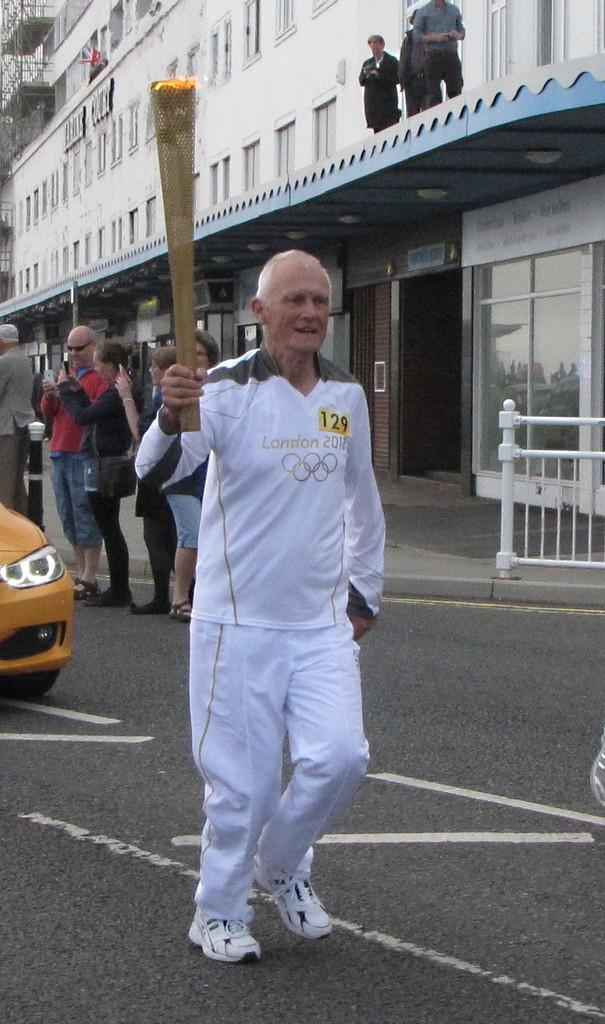Please provide a concise description of this image. In the center of the image we can see a man standing and holding an olympic lamp in his hand. In the background there are people. On the left there is a car on the road. In the background there is a building and we can see people standing on the building. 